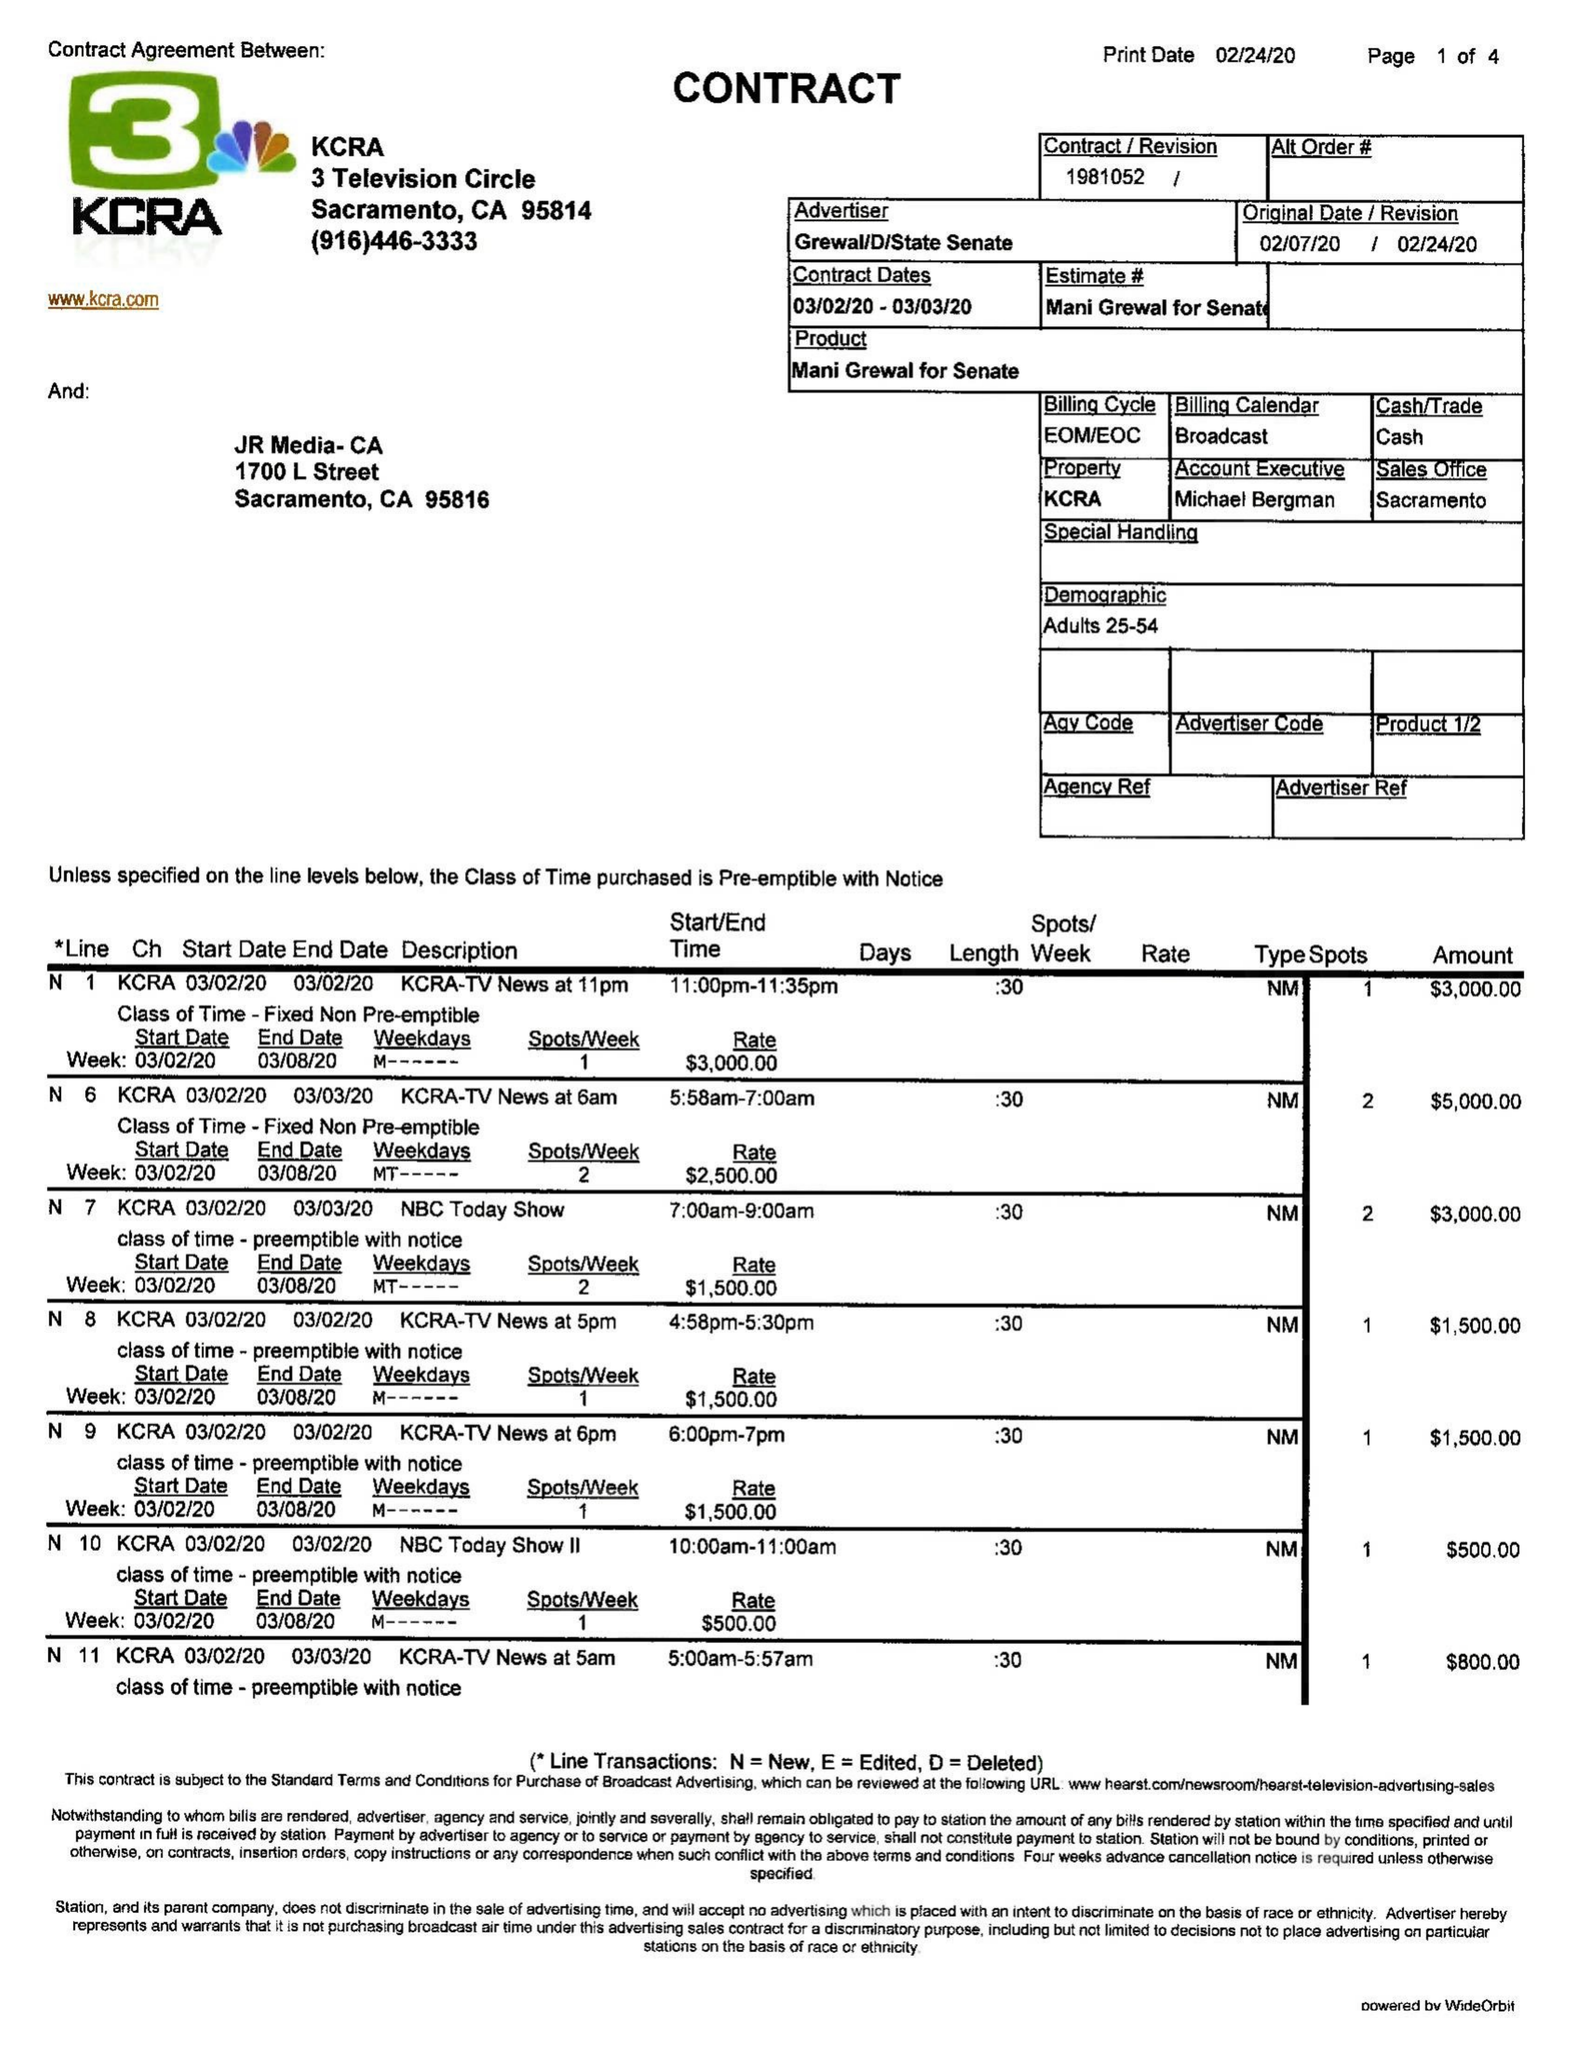What is the value for the contract_num?
Answer the question using a single word or phrase. 1981052 